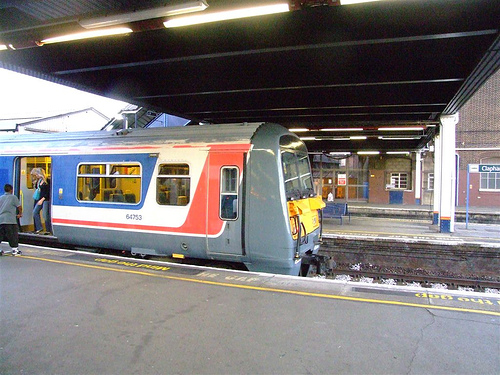Can you describe the style and features of the train? The train in the image features a modern design with a combination of white, red, and blue colors. It has a streamlined shape with passenger windows evenly spaced along its side, and the open door suggests it's accessible to passengers. 